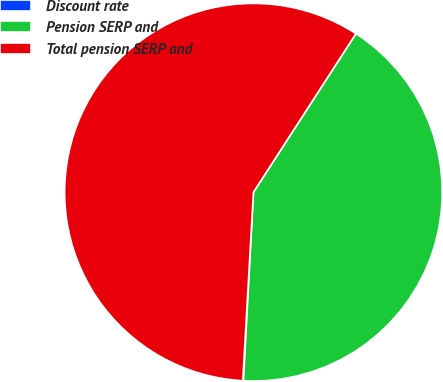Convert chart. <chart><loc_0><loc_0><loc_500><loc_500><pie_chart><fcel>Discount rate<fcel>Pension SERP and<fcel>Total pension SERP and<nl><fcel>0.06%<fcel>41.71%<fcel>58.24%<nl></chart> 